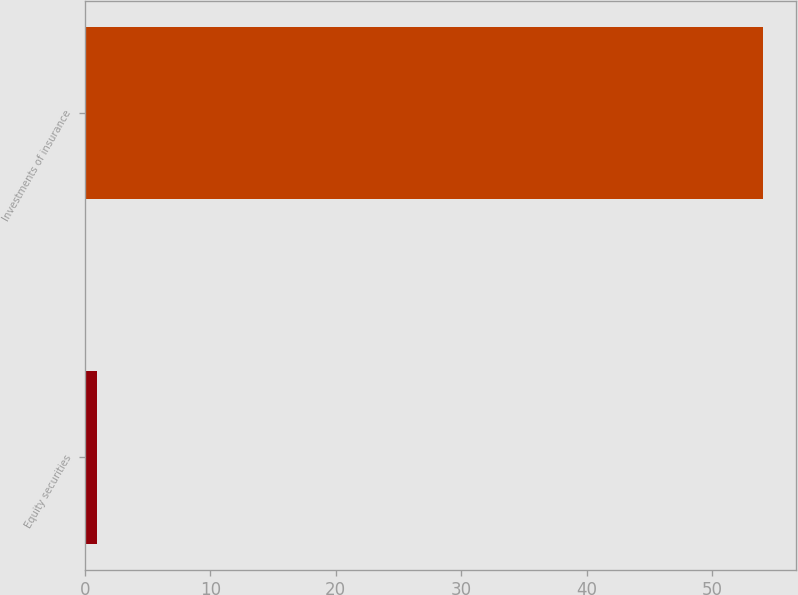Convert chart to OTSL. <chart><loc_0><loc_0><loc_500><loc_500><bar_chart><fcel>Equity securities<fcel>Investments of insurance<nl><fcel>1<fcel>54<nl></chart> 